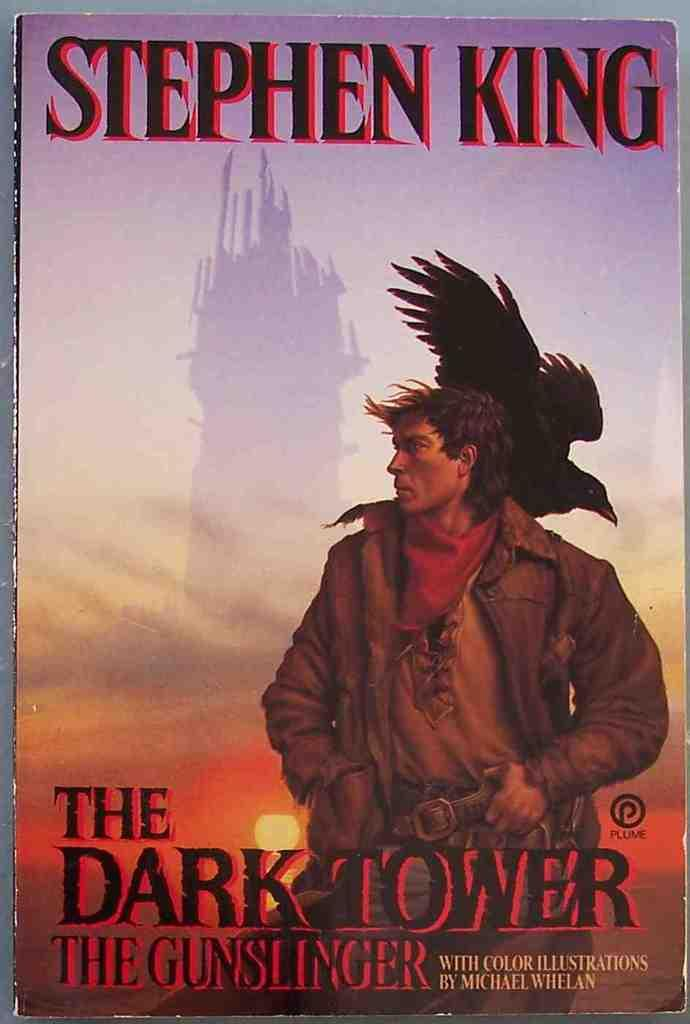<image>
Share a concise interpretation of the image provided. Chapter book from Stephen King the dark tower 